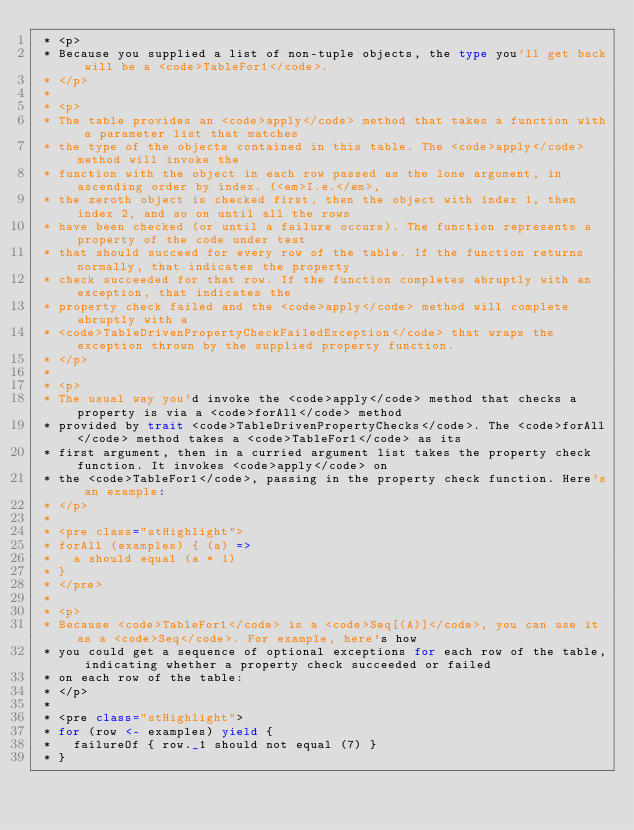<code> <loc_0><loc_0><loc_500><loc_500><_Scala_> * <p>
 * Because you supplied a list of non-tuple objects, the type you'll get back will be a <code>TableFor1</code>.
 * </p>
 *
 * <p>
 * The table provides an <code>apply</code> method that takes a function with a parameter list that matches
 * the type of the objects contained in this table. The <code>apply</code> method will invoke the
 * function with the object in each row passed as the lone argument, in ascending order by index. (<em>I.e.</em>,
 * the zeroth object is checked first, then the object with index 1, then index 2, and so on until all the rows
 * have been checked (or until a failure occurs). The function represents a property of the code under test
 * that should succeed for every row of the table. If the function returns normally, that indicates the property
 * check succeeded for that row. If the function completes abruptly with an exception, that indicates the
 * property check failed and the <code>apply</code> method will complete abruptly with a
 * <code>TableDrivenPropertyCheckFailedException</code> that wraps the exception thrown by the supplied property function.
 * </p>
 * 
 * <p>
 * The usual way you'd invoke the <code>apply</code> method that checks a property is via a <code>forAll</code> method
 * provided by trait <code>TableDrivenPropertyChecks</code>. The <code>forAll</code> method takes a <code>TableFor1</code> as its
 * first argument, then in a curried argument list takes the property check function. It invokes <code>apply</code> on
 * the <code>TableFor1</code>, passing in the property check function. Here's an example:
 * </p>
 *
 * <pre class="stHighlight">
 * forAll (examples) { (a) =>
 *   a should equal (a * 1)
 * }
 * </pre>
 *
 * <p>
 * Because <code>TableFor1</code> is a <code>Seq[(A)]</code>, you can use it as a <code>Seq</code>. For example, here's how
 * you could get a sequence of optional exceptions for each row of the table, indicating whether a property check succeeded or failed
 * on each row of the table:
 * </p>
 *
 * <pre class="stHighlight">
 * for (row <- examples) yield {
 *   failureOf { row._1 should not equal (7) }
 * }</code> 